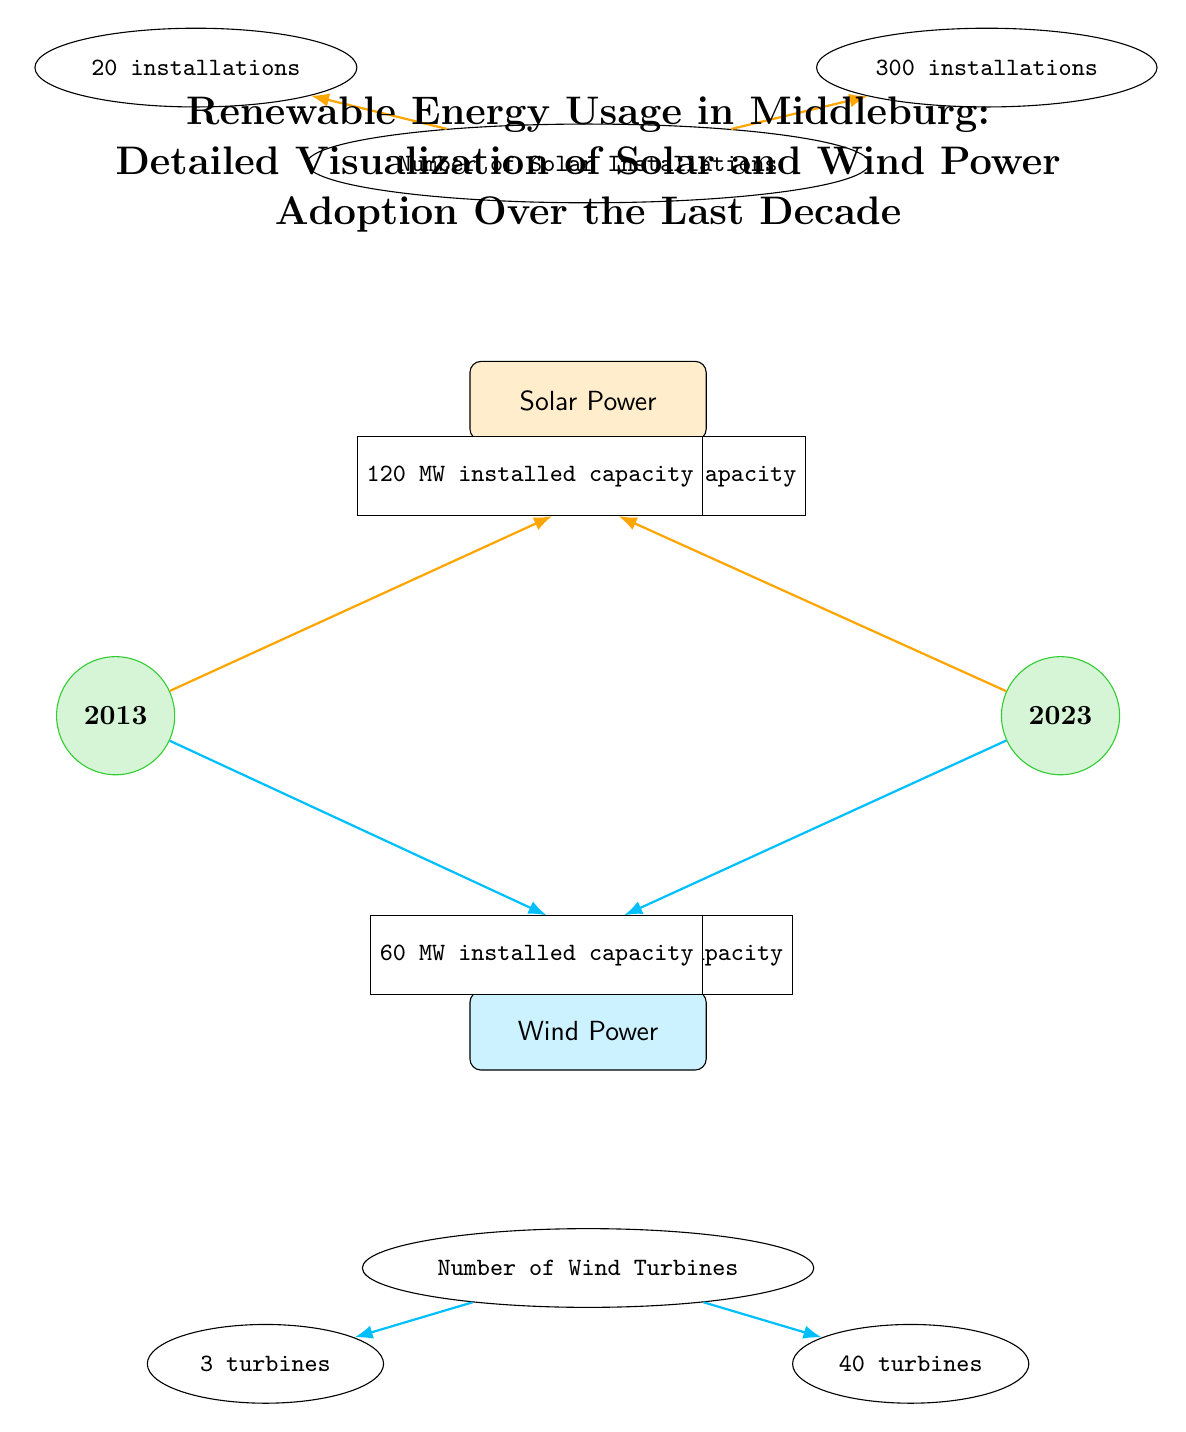What was the installed capacity of solar power in 2013? The diagram indicates that in 2013, the installed capacity of solar power was represented next to the solar power node, stating "10 MW installed capacity."
Answer: 10 MW installed capacity How many wind turbines were there in Middleburg in 2023? The diagram shows that by 2023, the number of wind turbines is specified next to the wind turbines node, which states "40 turbines."
Answer: 40 turbines What is the total increase in solar installations from 2013 to 2023? According to the diagram, in 2013, there were "20 installations" and in 2023, there were "300 installations." The increase is calculated as 300 - 20 = 280.
Answer: 280 installations What type of energy saw a higher growth rate over the decade? The diagram shows a difference of 110 MW for solar (from 10 MW to 120 MW) and 55 MW for wind (from 5 MW to 60 MW), indicating solar power had a higher growth rate in terms of installed capacity.
Answer: Solar Power What is the total installed capacity of both solar and wind power in 2023? The diagram states "120 MW installed capacity" for solar and "60 MW installed capacity" for wind. Adding these together gives a total of 120 + 60 = 180 MW.
Answer: 180 MW 